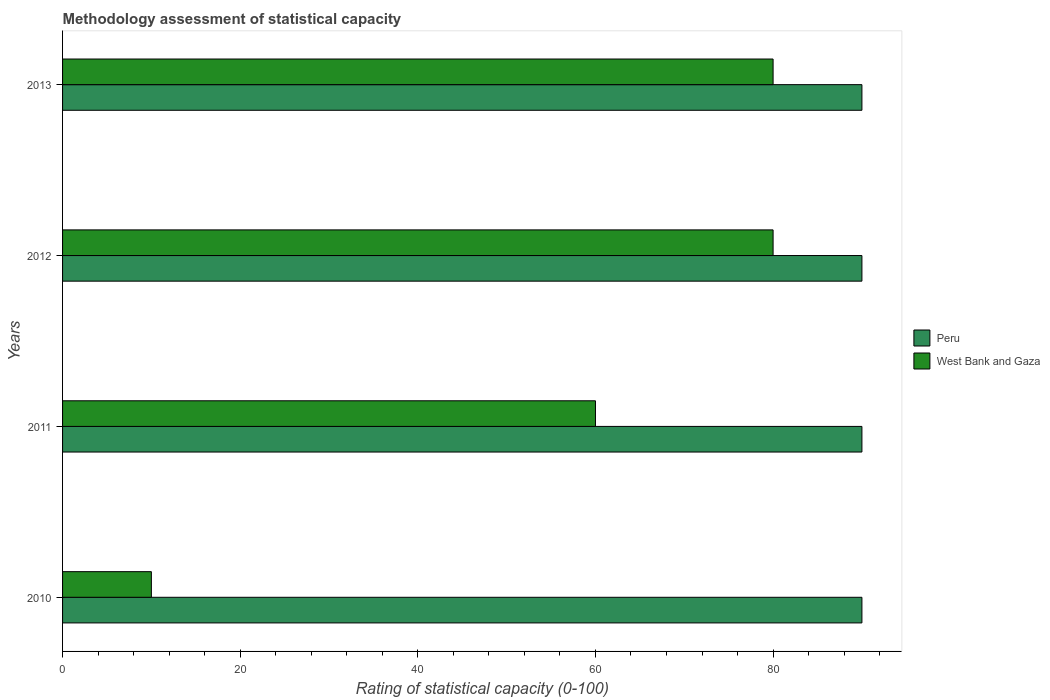How many different coloured bars are there?
Keep it short and to the point. 2. How many groups of bars are there?
Your answer should be compact. 4. Are the number of bars per tick equal to the number of legend labels?
Provide a short and direct response. Yes. How many bars are there on the 3rd tick from the top?
Offer a terse response. 2. What is the rating of statistical capacity in Peru in 2010?
Offer a very short reply. 90. Across all years, what is the minimum rating of statistical capacity in Peru?
Ensure brevity in your answer.  90. What is the total rating of statistical capacity in Peru in the graph?
Keep it short and to the point. 360. What is the difference between the rating of statistical capacity in Peru in 2010 and the rating of statistical capacity in West Bank and Gaza in 2012?
Make the answer very short. 10. In the year 2010, what is the difference between the rating of statistical capacity in West Bank and Gaza and rating of statistical capacity in Peru?
Make the answer very short. -80. In how many years, is the rating of statistical capacity in West Bank and Gaza greater than 56 ?
Ensure brevity in your answer.  3. Is the rating of statistical capacity in Peru in 2011 less than that in 2012?
Your answer should be compact. No. What is the difference between the highest and the second highest rating of statistical capacity in West Bank and Gaza?
Make the answer very short. 0. Is the sum of the rating of statistical capacity in West Bank and Gaza in 2012 and 2013 greater than the maximum rating of statistical capacity in Peru across all years?
Give a very brief answer. Yes. What does the 2nd bar from the bottom in 2013 represents?
Keep it short and to the point. West Bank and Gaza. How many bars are there?
Your answer should be compact. 8. How many years are there in the graph?
Provide a succinct answer. 4. Are the values on the major ticks of X-axis written in scientific E-notation?
Your response must be concise. No. Does the graph contain any zero values?
Give a very brief answer. No. Does the graph contain grids?
Offer a very short reply. No. Where does the legend appear in the graph?
Offer a very short reply. Center right. How many legend labels are there?
Offer a terse response. 2. What is the title of the graph?
Give a very brief answer. Methodology assessment of statistical capacity. What is the label or title of the X-axis?
Offer a very short reply. Rating of statistical capacity (0-100). What is the label or title of the Y-axis?
Provide a short and direct response. Years. What is the Rating of statistical capacity (0-100) of Peru in 2010?
Your answer should be compact. 90. What is the Rating of statistical capacity (0-100) in West Bank and Gaza in 2010?
Give a very brief answer. 10. What is the Rating of statistical capacity (0-100) in West Bank and Gaza in 2012?
Offer a very short reply. 80. Across all years, what is the minimum Rating of statistical capacity (0-100) in Peru?
Make the answer very short. 90. Across all years, what is the minimum Rating of statistical capacity (0-100) in West Bank and Gaza?
Provide a succinct answer. 10. What is the total Rating of statistical capacity (0-100) in Peru in the graph?
Provide a succinct answer. 360. What is the total Rating of statistical capacity (0-100) in West Bank and Gaza in the graph?
Ensure brevity in your answer.  230. What is the difference between the Rating of statistical capacity (0-100) in West Bank and Gaza in 2010 and that in 2012?
Give a very brief answer. -70. What is the difference between the Rating of statistical capacity (0-100) in West Bank and Gaza in 2010 and that in 2013?
Your response must be concise. -70. What is the difference between the Rating of statistical capacity (0-100) in Peru in 2011 and that in 2013?
Offer a terse response. 0. What is the difference between the Rating of statistical capacity (0-100) in Peru in 2010 and the Rating of statistical capacity (0-100) in West Bank and Gaza in 2011?
Provide a succinct answer. 30. What is the difference between the Rating of statistical capacity (0-100) of Peru in 2010 and the Rating of statistical capacity (0-100) of West Bank and Gaza in 2012?
Offer a very short reply. 10. What is the difference between the Rating of statistical capacity (0-100) in Peru in 2011 and the Rating of statistical capacity (0-100) in West Bank and Gaza in 2013?
Give a very brief answer. 10. What is the difference between the Rating of statistical capacity (0-100) in Peru in 2012 and the Rating of statistical capacity (0-100) in West Bank and Gaza in 2013?
Give a very brief answer. 10. What is the average Rating of statistical capacity (0-100) in Peru per year?
Your answer should be compact. 90. What is the average Rating of statistical capacity (0-100) of West Bank and Gaza per year?
Your response must be concise. 57.5. In the year 2012, what is the difference between the Rating of statistical capacity (0-100) in Peru and Rating of statistical capacity (0-100) in West Bank and Gaza?
Your response must be concise. 10. In the year 2013, what is the difference between the Rating of statistical capacity (0-100) of Peru and Rating of statistical capacity (0-100) of West Bank and Gaza?
Your answer should be very brief. 10. What is the ratio of the Rating of statistical capacity (0-100) of Peru in 2010 to that in 2011?
Make the answer very short. 1. What is the ratio of the Rating of statistical capacity (0-100) in Peru in 2011 to that in 2012?
Provide a succinct answer. 1. What is the ratio of the Rating of statistical capacity (0-100) in Peru in 2011 to that in 2013?
Your answer should be very brief. 1. What is the ratio of the Rating of statistical capacity (0-100) of West Bank and Gaza in 2011 to that in 2013?
Your answer should be compact. 0.75. What is the difference between the highest and the lowest Rating of statistical capacity (0-100) of Peru?
Ensure brevity in your answer.  0. What is the difference between the highest and the lowest Rating of statistical capacity (0-100) in West Bank and Gaza?
Make the answer very short. 70. 